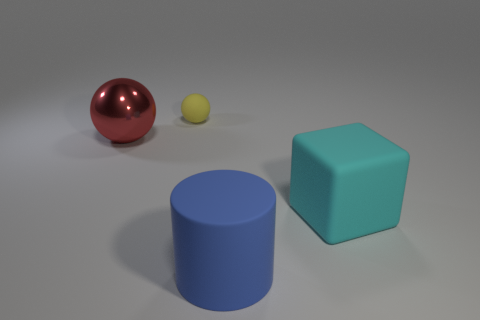There is a red sphere; does it have the same size as the rubber thing to the left of the large blue rubber object?
Your answer should be compact. No. Is there a large red metal sphere that is on the left side of the large object that is to the right of the cylinder?
Make the answer very short. Yes. The object that is in front of the yellow rubber thing and behind the cyan thing is made of what material?
Give a very brief answer. Metal. The sphere that is in front of the sphere behind the ball in front of the small ball is what color?
Ensure brevity in your answer.  Red. The matte object that is the same size as the cube is what color?
Your response must be concise. Blue. Is the color of the tiny object the same as the big rubber object left of the large cyan matte block?
Provide a short and direct response. No. What material is the red ball that is to the left of the thing on the right side of the cylinder made of?
Ensure brevity in your answer.  Metal. What number of rubber objects are left of the big blue rubber thing and in front of the yellow thing?
Provide a succinct answer. 0. How many other objects are the same size as the blue cylinder?
Your answer should be very brief. 2. There is a big object to the left of the small rubber ball; is it the same shape as the matte thing to the left of the large rubber cylinder?
Make the answer very short. Yes. 